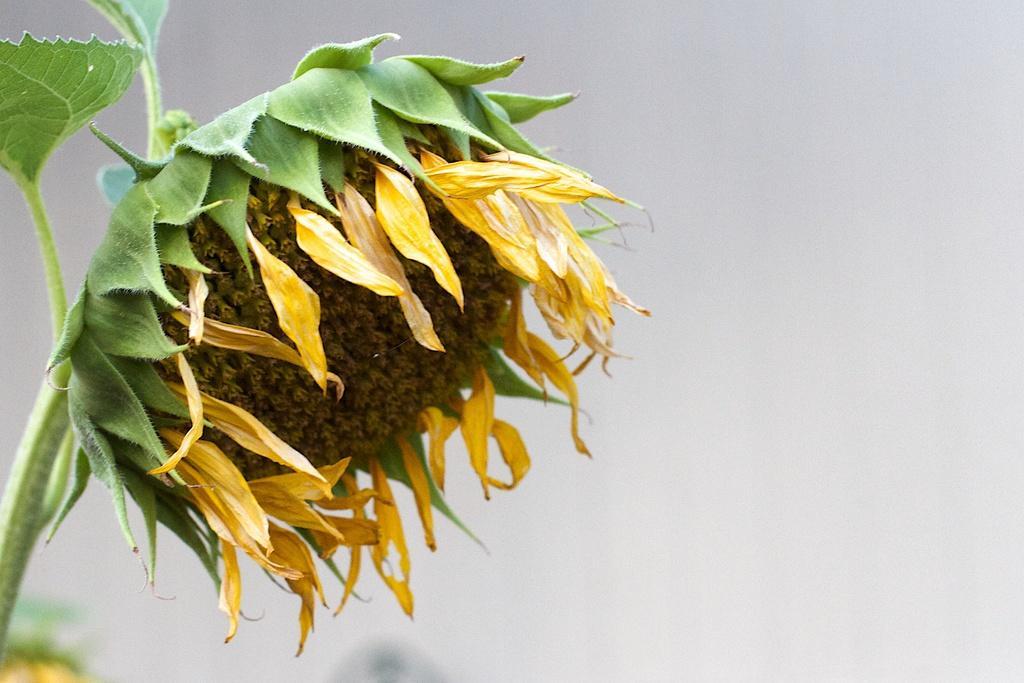How would you summarize this image in a sentence or two? This image is taken outdoors. On the left side of the image there is a plant with a sunflower. 